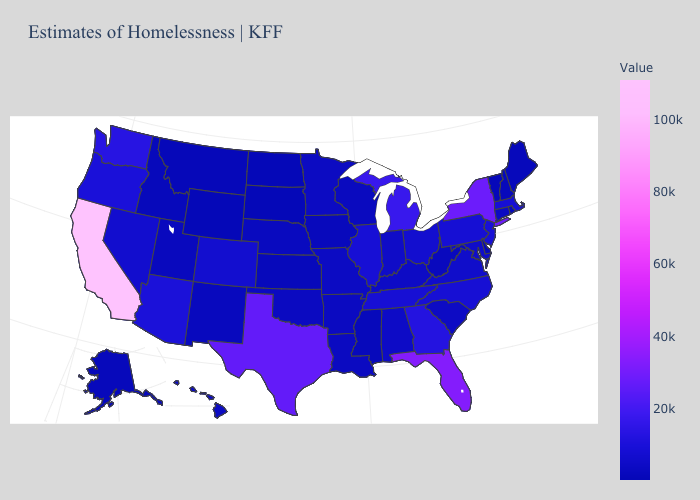Which states have the highest value in the USA?
Concise answer only. California. Among the states that border Colorado , does Arizona have the highest value?
Keep it brief. Yes. Among the states that border West Virginia , does Ohio have the lowest value?
Be succinct. No. Does New York have the highest value in the Northeast?
Give a very brief answer. Yes. 